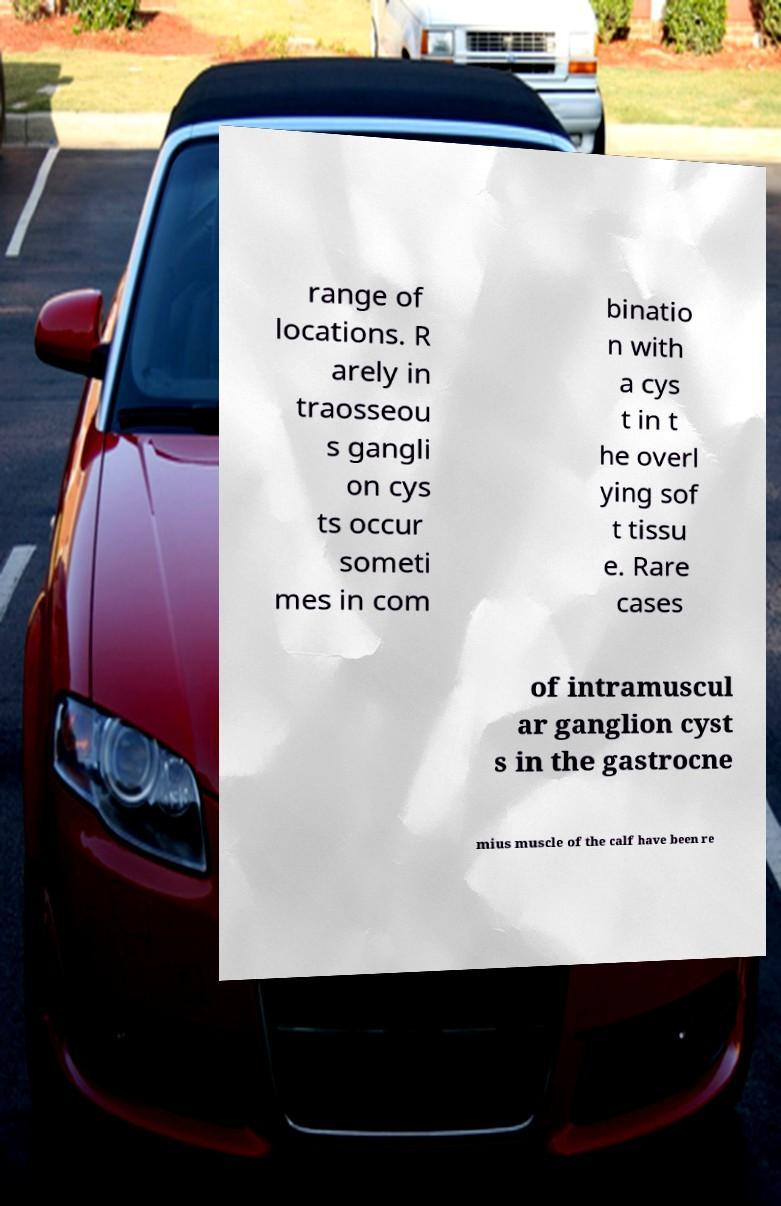Could you assist in decoding the text presented in this image and type it out clearly? range of locations. R arely in traosseou s gangli on cys ts occur someti mes in com binatio n with a cys t in t he overl ying sof t tissu e. Rare cases of intramuscul ar ganglion cyst s in the gastrocne mius muscle of the calf have been re 